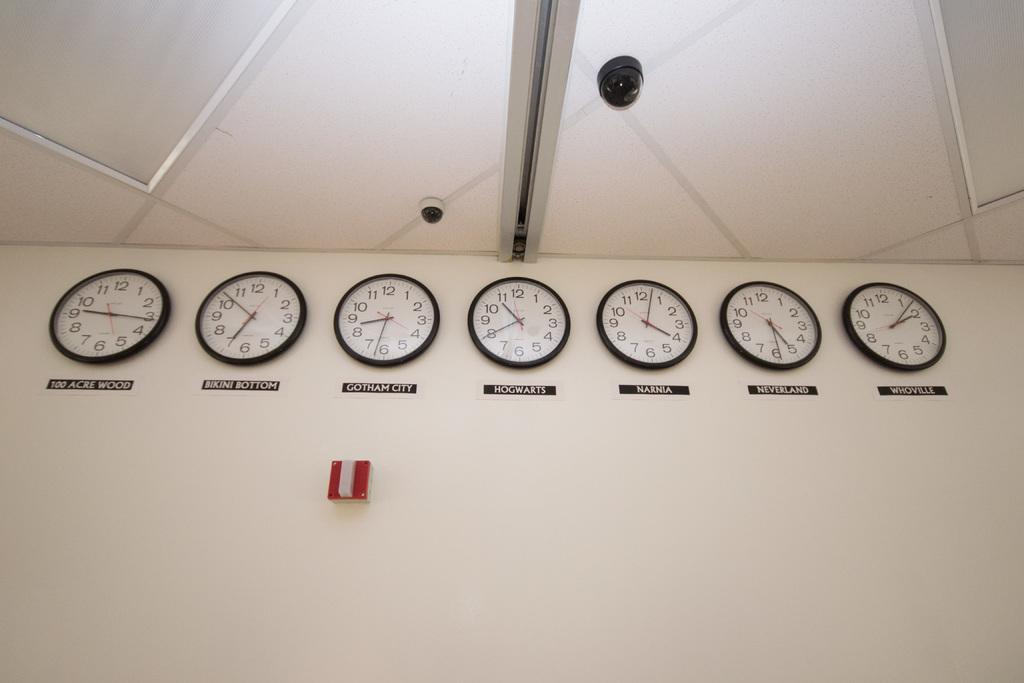What is the clock on the right for?
Give a very brief answer. Whoville. What country is the clock in the very center telling the time for?
Give a very brief answer. Hogwarts. 